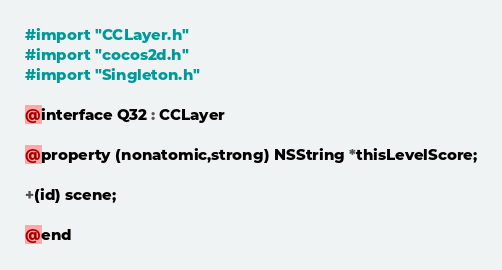<code> <loc_0><loc_0><loc_500><loc_500><_C_>#import "CCLayer.h"
#import "cocos2d.h"
#import "Singleton.h"

@interface Q32 : CCLayer

@property (nonatomic,strong) NSString *thisLevelScore;

+(id) scene;

@end
</code> 